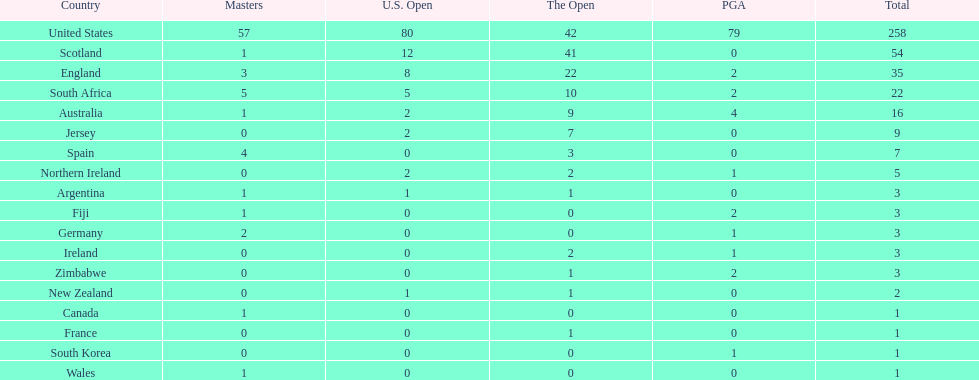What is the count of zimbabwean golfers who have achieved pga victories? 2. 